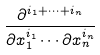Convert formula to latex. <formula><loc_0><loc_0><loc_500><loc_500>\frac { \partial ^ { i _ { 1 } + \cdots + i _ { n } } } { \partial x _ { 1 } ^ { i _ { 1 } } \cdots \partial x _ { n } ^ { i _ { n } } }</formula> 